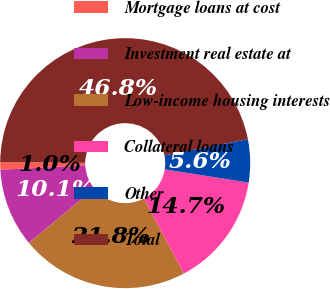Convert chart to OTSL. <chart><loc_0><loc_0><loc_500><loc_500><pie_chart><fcel>Mortgage loans at cost<fcel>Investment real estate at<fcel>Low-income housing interests<fcel>Collateral loans<fcel>Other<fcel>Total<nl><fcel>0.99%<fcel>10.15%<fcel>21.79%<fcel>14.73%<fcel>5.57%<fcel>46.79%<nl></chart> 